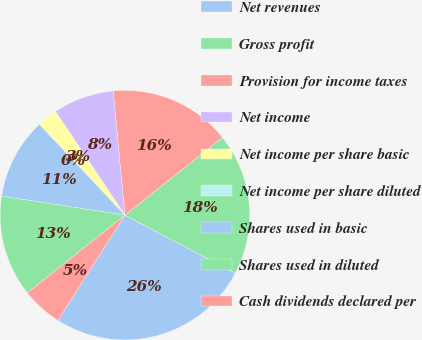Convert chart to OTSL. <chart><loc_0><loc_0><loc_500><loc_500><pie_chart><fcel>Net revenues<fcel>Gross profit<fcel>Provision for income taxes<fcel>Net income<fcel>Net income per share basic<fcel>Net income per share diluted<fcel>Shares used in basic<fcel>Shares used in diluted<fcel>Cash dividends declared per<nl><fcel>26.31%<fcel>18.42%<fcel>15.79%<fcel>7.9%<fcel>2.63%<fcel>0.0%<fcel>10.53%<fcel>13.16%<fcel>5.26%<nl></chart> 